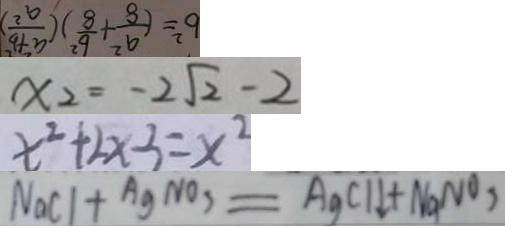<formula> <loc_0><loc_0><loc_500><loc_500>b ^ { 2 } = ( \frac { a ^ { 2 } } { 8 } + \frac { b ^ { 2 } } { 8 } ) ( \frac { a ^ { 2 } + b ^ { 2 } } { a ^ { 2 } } ) 
 x _ { 2 } = - 2 \sqrt { 2 } - 2 
 x ^ { 2 } + 2 x - 3 = x ^ { 2 } 
 N a C l + A g N O _ { 3 } = A g C l \downarrow + N a N O _ { 3 }</formula> 